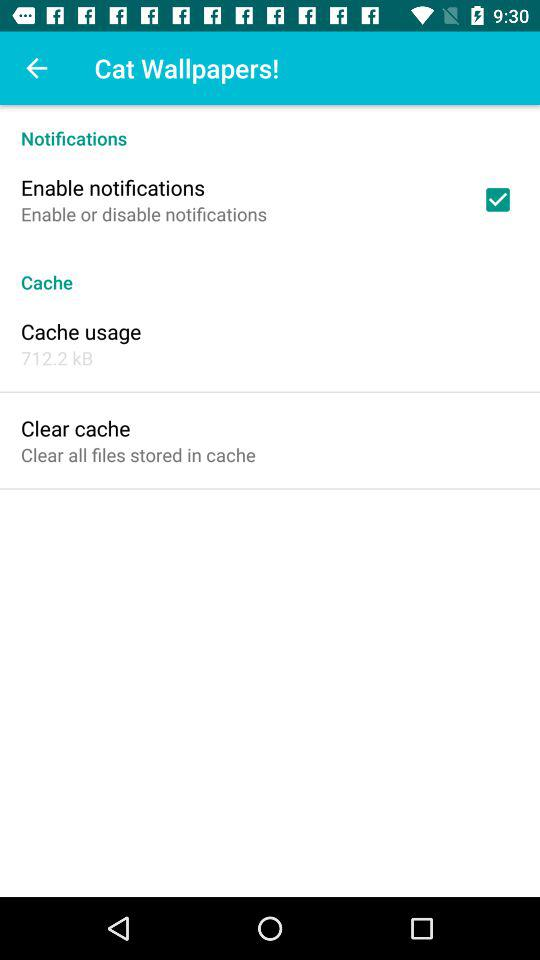What notification is checked? The checked notification is "Enable notifications". 